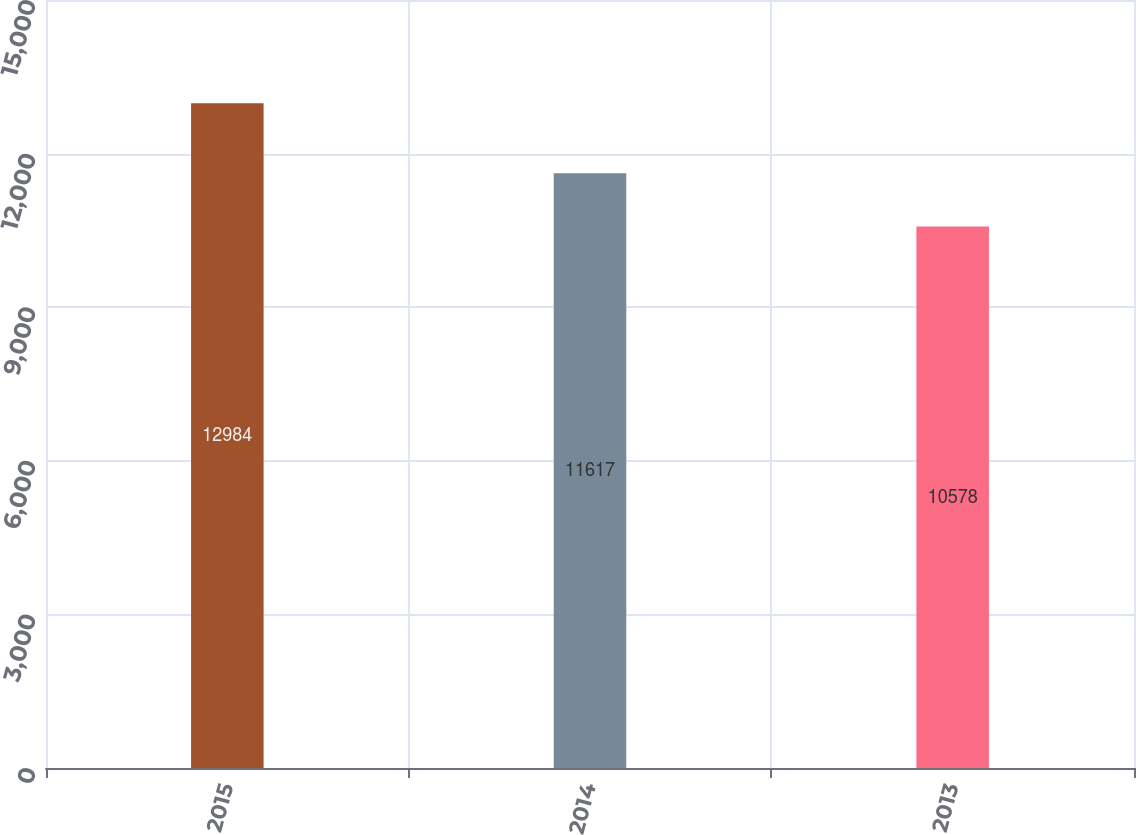<chart> <loc_0><loc_0><loc_500><loc_500><bar_chart><fcel>2015<fcel>2014<fcel>2013<nl><fcel>12984<fcel>11617<fcel>10578<nl></chart> 